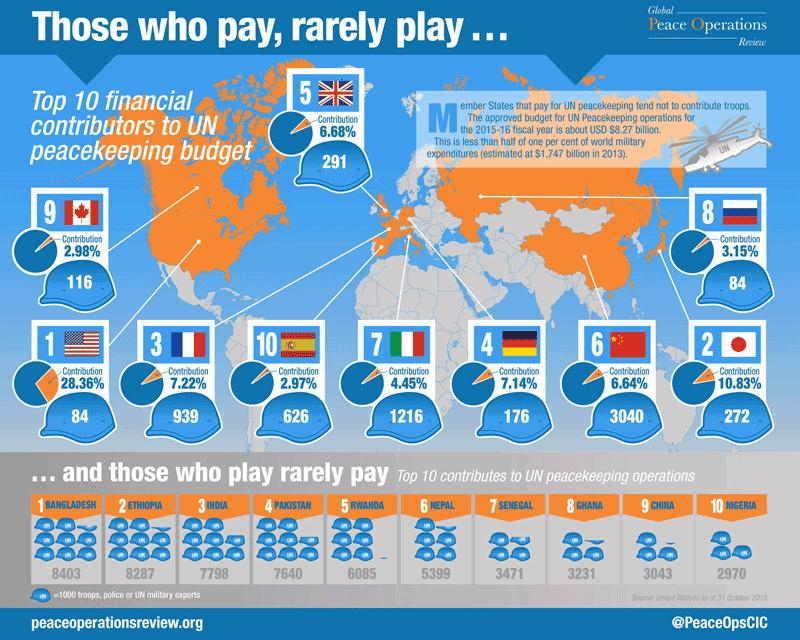Draw attention to some important aspects in this diagram. In the 2015-2016 fiscal year, the United Nations peacekeeping budget was approximately 6.68% contributed by the United Kingdom. During the 2015-16 fiscal year, a total of 5399 task forces were deployed by Nepal to UN peacekeeping operations. During the 2015-16 fiscal year, a total of 7,798 task forces were deployed by India to United Nations peacekeeping operations. During the 2015-16 fiscal year, China's contribution to the UN peacekeeping budget was 6.64% of the total budget. During the 2015-16 fiscal year, Ethiopia deployed a total of 8,287 task forces to United Nations peacekeeping operations. 